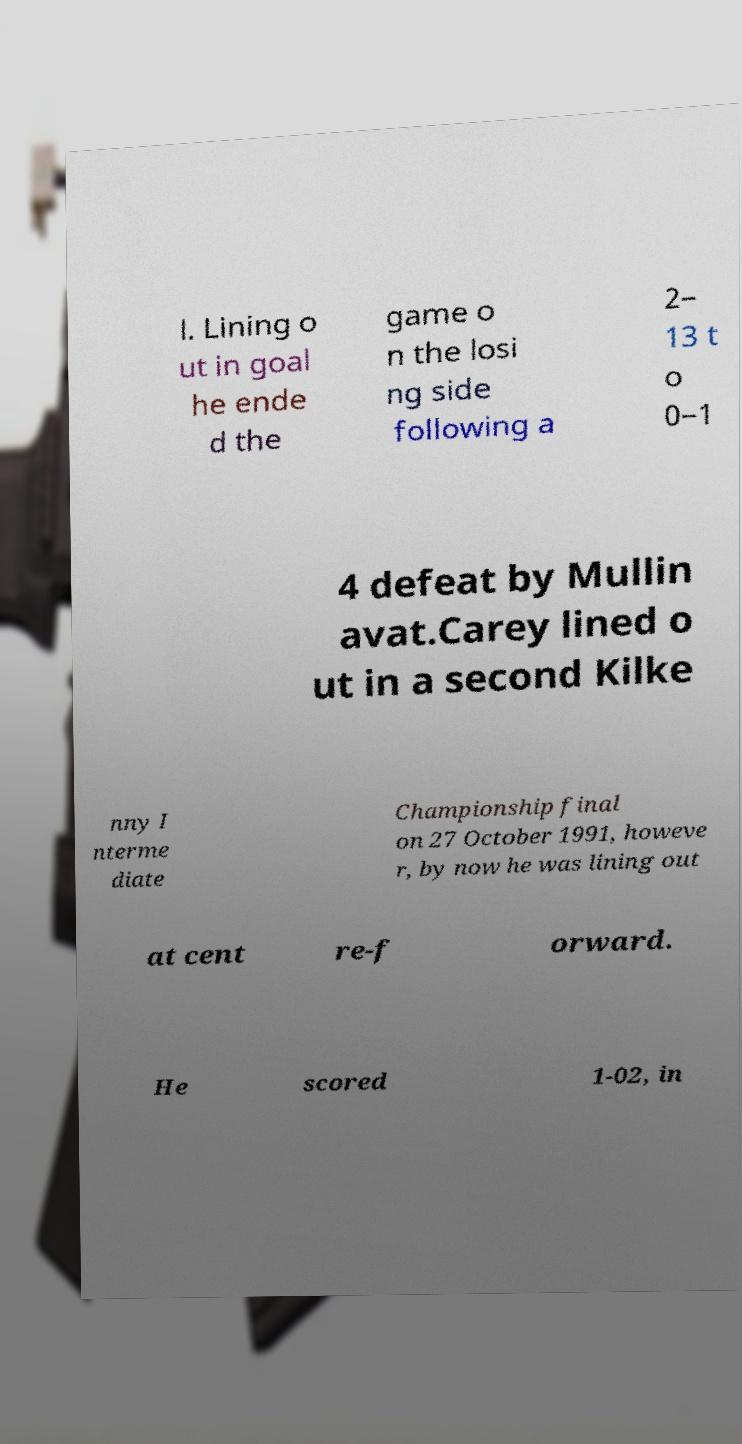Please identify and transcribe the text found in this image. l. Lining o ut in goal he ende d the game o n the losi ng side following a 2– 13 t o 0–1 4 defeat by Mullin avat.Carey lined o ut in a second Kilke nny I nterme diate Championship final on 27 October 1991, howeve r, by now he was lining out at cent re-f orward. He scored 1-02, in 